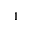<formula> <loc_0><loc_0><loc_500><loc_500>^ { 1 }</formula> 